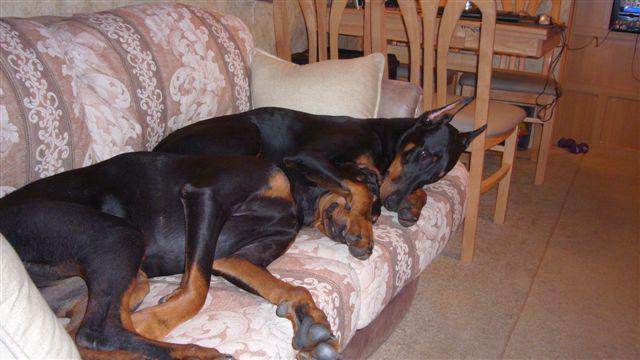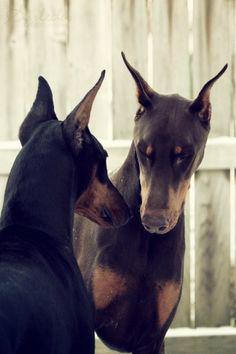The first image is the image on the left, the second image is the image on the right. Evaluate the accuracy of this statement regarding the images: "Each image contains two dobermans, and the left image depicts dobermans reclining on a sofa.". Is it true? Answer yes or no. Yes. 